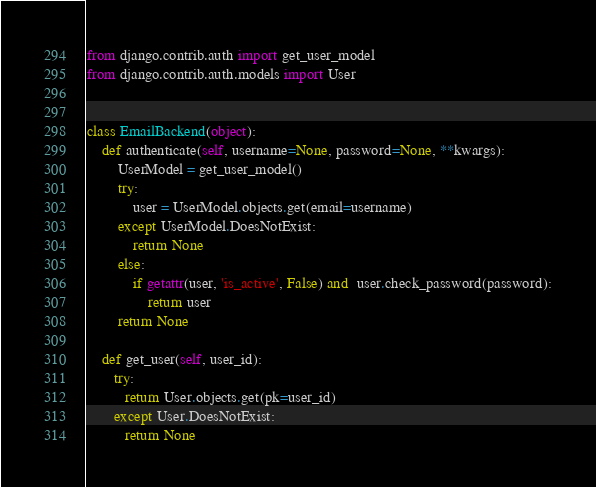Convert code to text. <code><loc_0><loc_0><loc_500><loc_500><_Python_>from django.contrib.auth import get_user_model
from django.contrib.auth.models import User


class EmailBackend(object):
    def authenticate(self, username=None, password=None, **kwargs):
        UserModel = get_user_model()
        try:
            user = UserModel.objects.get(email=username)
        except UserModel.DoesNotExist:
            return None
        else:
            if getattr(user, 'is_active', False) and  user.check_password(password):
                return user
        return None

    def get_user(self, user_id):
       try:
          return User.objects.get(pk=user_id)
       except User.DoesNotExist:
          return None
</code> 